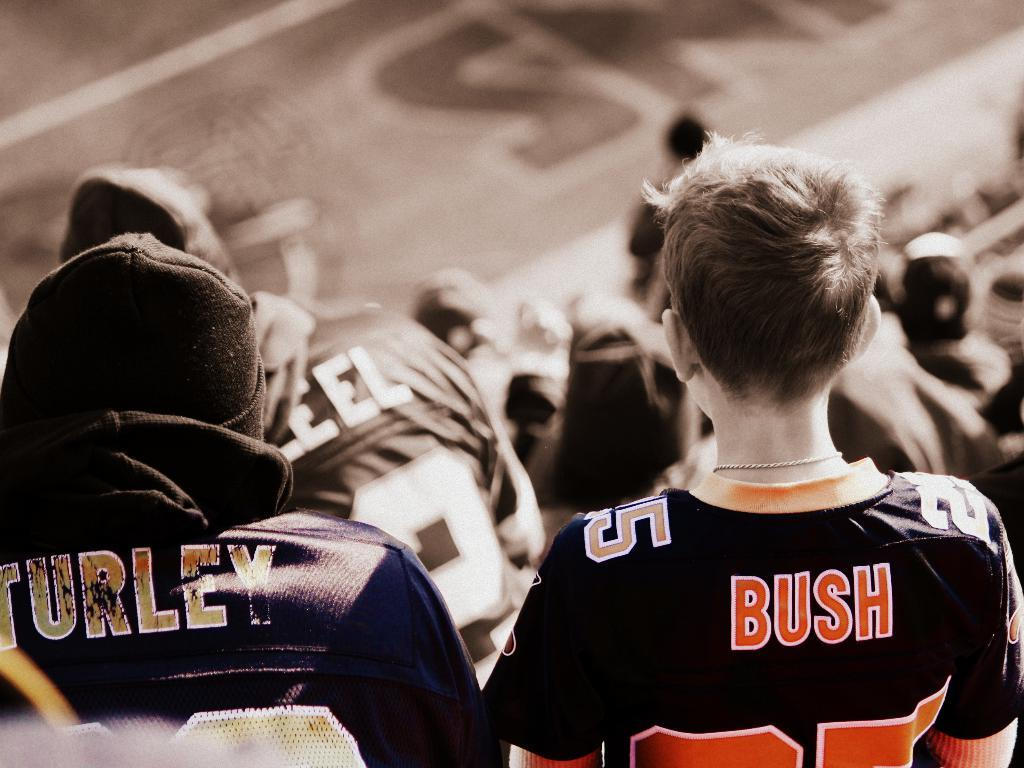<image>
Describe the image concisely. two people in a crowd with Bush and Turley jerseys on. 